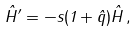Convert formula to latex. <formula><loc_0><loc_0><loc_500><loc_500>\hat { H } ^ { \prime } = - s ( 1 + \hat { q } ) \hat { H } \, ,</formula> 